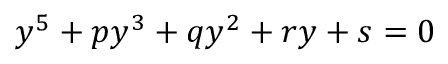<formula> <loc_0><loc_0><loc_500><loc_500>y ^ { 5 } + p y ^ { 3 } + q y ^ { 2 } + r y + s = 0</formula> 